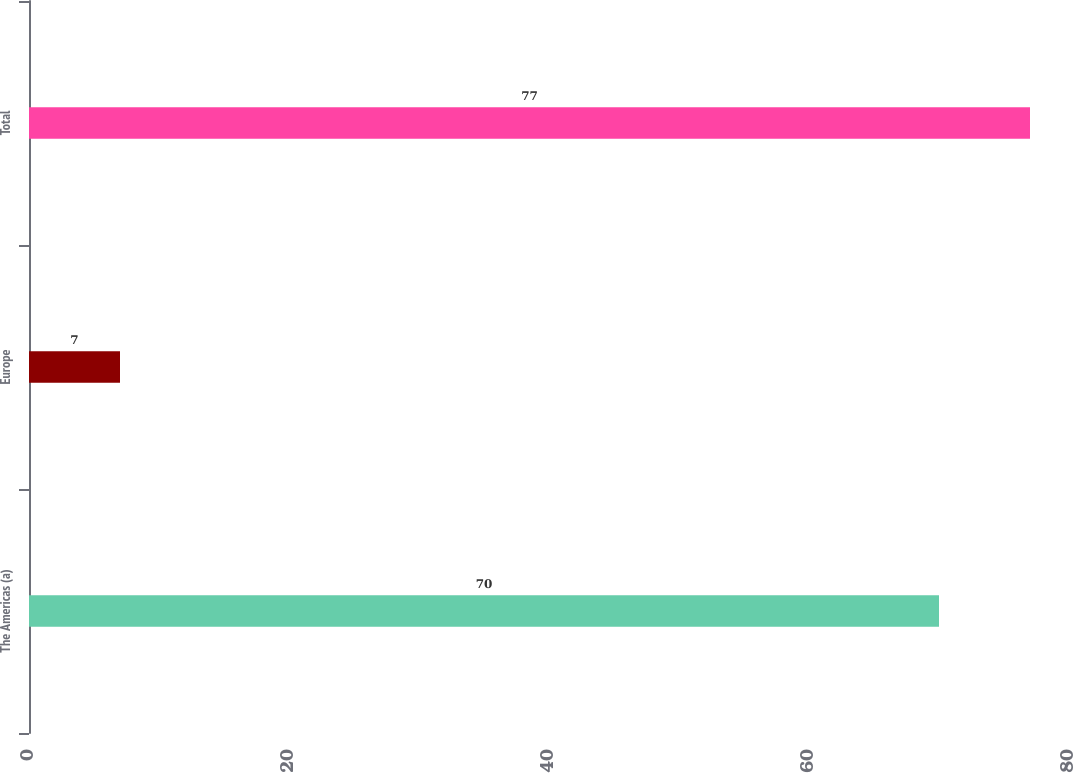<chart> <loc_0><loc_0><loc_500><loc_500><bar_chart><fcel>The Americas (a)<fcel>Europe<fcel>Total<nl><fcel>70<fcel>7<fcel>77<nl></chart> 